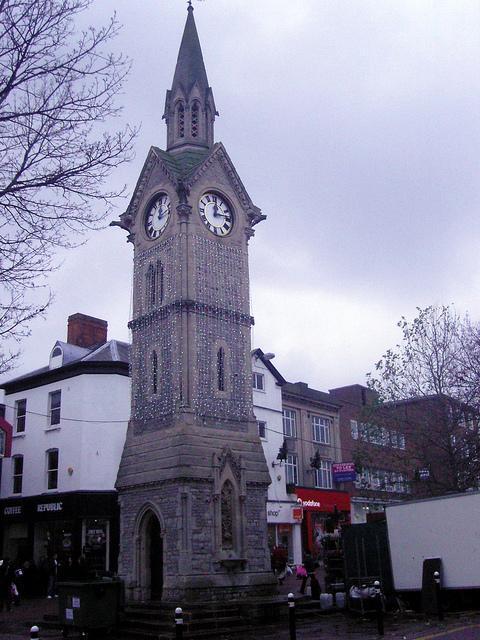How many of the chairs are blue?
Give a very brief answer. 0. 